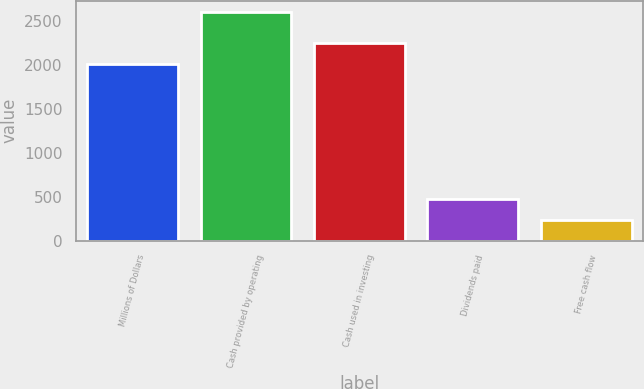<chart> <loc_0><loc_0><loc_500><loc_500><bar_chart><fcel>Millions of Dollars<fcel>Cash provided by operating<fcel>Cash used in investing<fcel>Dividends paid<fcel>Free cash flow<nl><fcel>2005<fcel>2595<fcel>2241.1<fcel>470.1<fcel>234<nl></chart> 